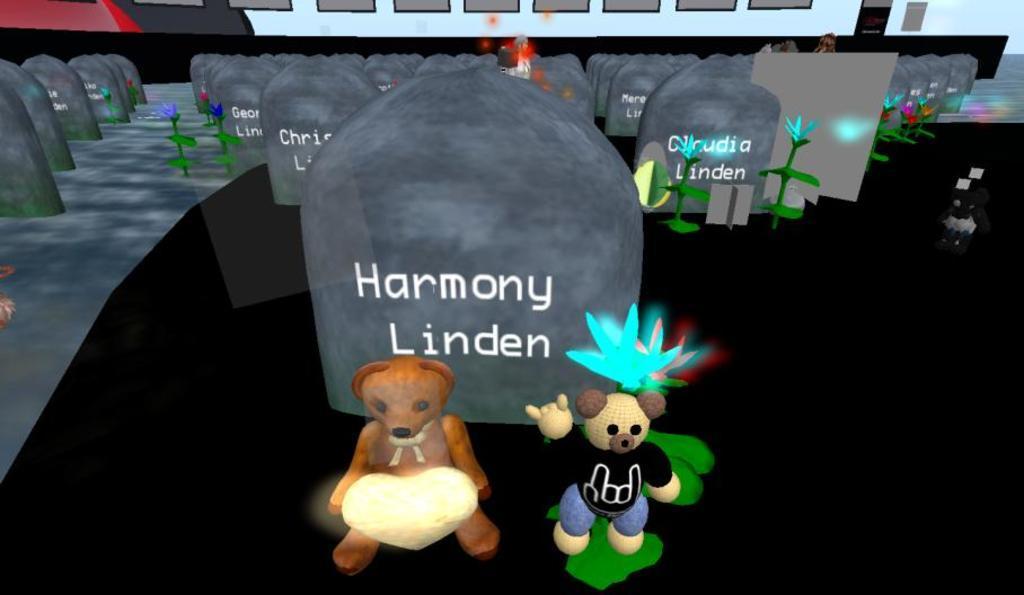How would you summarize this image in a sentence or two? This is an animated picture. Here we can see cartoons, stone plates, plants, and flowers. 